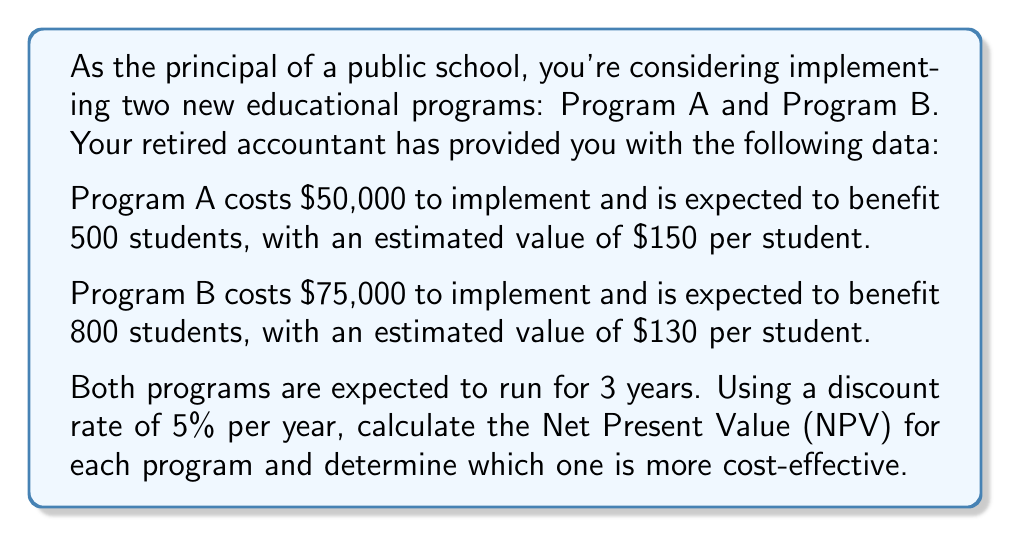What is the answer to this math problem? To solve this problem, we'll follow these steps:

1. Calculate the total benefit for each program per year
2. Calculate the Present Value (PV) of benefits for each year
3. Sum the PV of benefits for all 3 years
4. Subtract the initial cost to get the Net Present Value (NPV)
5. Compare the NPVs to determine which program is more cost-effective

For Program A:
1. Total benefit per year = 500 students × $150 per student = $75,000

2. PV of benefits for each year:
   Year 1: $\frac{75000}{(1 + 0.05)^1} = 71428.57$
   Year 2: $\frac{75000}{(1 + 0.05)^2} = 68027.21$
   Year 3: $\frac{75000}{(1 + 0.05)^3} = 64787.82$

3. Sum of PV of benefits = $71428.57 + 68027.21 + 64787.82 = 204243.60$

4. NPV = Sum of PV of benefits - Initial cost
   $NPV_A = 204243.60 - 50000 = 154243.60$

For Program B:
1. Total benefit per year = 800 students × $130 per student = $104,000

2. PV of benefits for each year:
   Year 1: $\frac{104000}{(1 + 0.05)^1} = 99047.62$
   Year 2: $\frac{104000}{(1 + 0.05)^2} = 94331.07$
   Year 3: $\frac{104000}{(1 + 0.05)^3} = 89839.11$

3. Sum of PV of benefits = $99047.62 + 94331.07 + 89839.11 = 283217.80$

4. NPV = Sum of PV of benefits - Initial cost
   $NPV_B = 283217.80 - 75000 = 208217.80$

5. Comparing NPVs:
   $NPV_A = 154243.60$
   $NPV_B = 208217.80$

Since $NPV_B > NPV_A$, Program B is more cost-effective.
Answer: Program B is more cost-effective with an NPV of $208,217.80, compared to Program A's NPV of $154,243.60. 